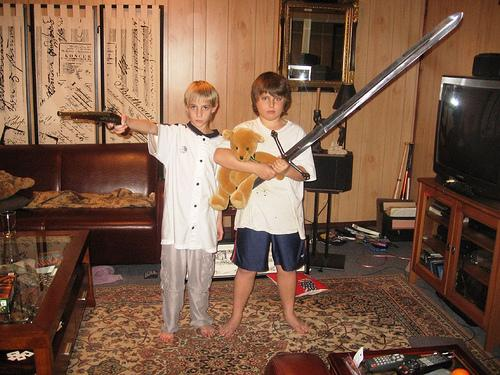What is the boy on the right holding? sword 